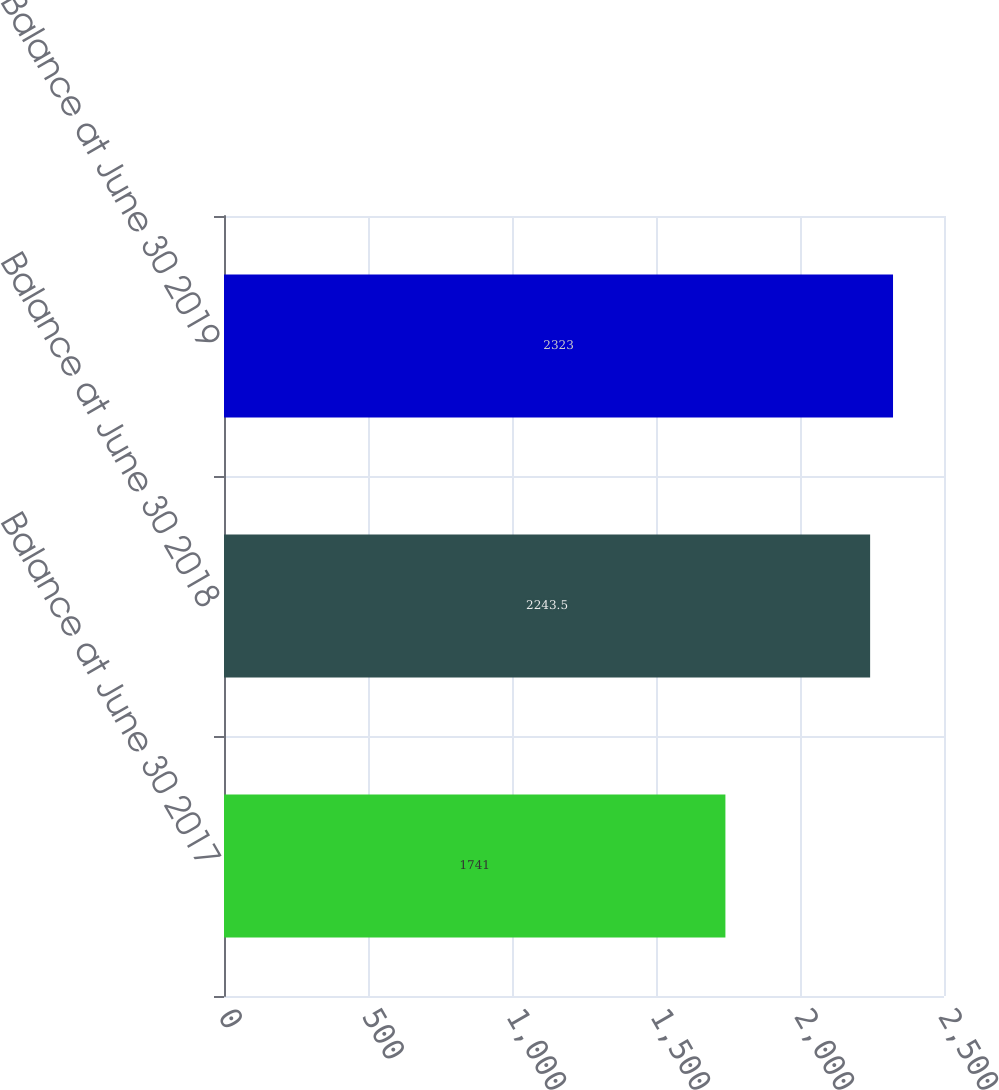Convert chart. <chart><loc_0><loc_0><loc_500><loc_500><bar_chart><fcel>Balance at June 30 2017<fcel>Balance at June 30 2018<fcel>Balance at June 30 2019<nl><fcel>1741<fcel>2243.5<fcel>2323<nl></chart> 